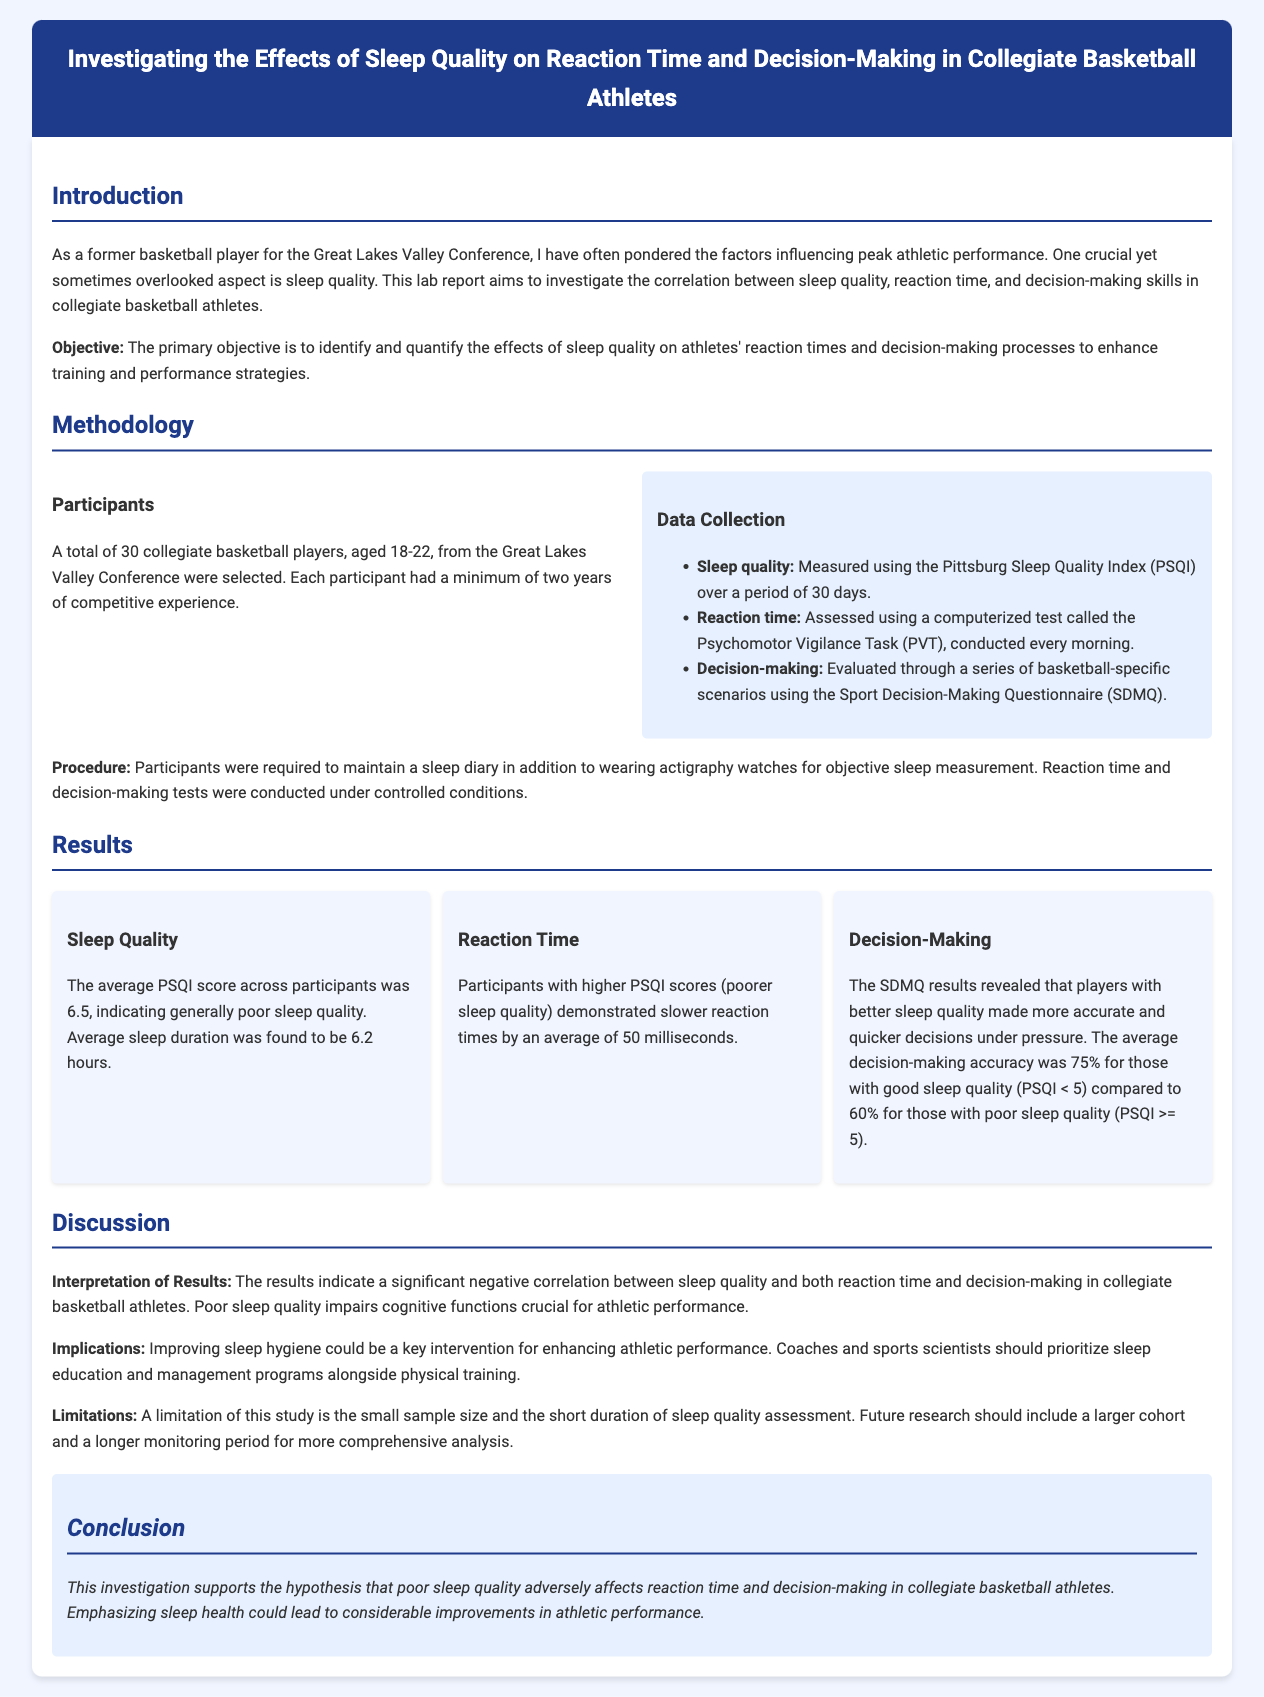what is the average PSQI score of participants? The average PSQI score across participants indicates generally poor sleep quality.
Answer: 6.5 how many collegiate basketball players participated in the study? The total number of collegiate basketball players selected for the study was specified in the document.
Answer: 30 what is the average sleep duration found in the study? The average sleep duration is based on the participant's sleep records over a specific period.
Answer: 6.2 hours how much slower were participants with poorer sleep quality in reaction times? Reaction times were measured and the impact of sleep quality on these times was analyzed.
Answer: 50 milliseconds what was the decision-making accuracy for those with good sleep quality? The decision-making results were reported as a percentage based on the PSQI scores of the participants.
Answer: 75% what is one implication suggested in the discussion? The discussion section highlights a recommendation based on the study's findings regarding sleep and athletic performance.
Answer: Sleep education what does the report suggest as a key intervention for enhancing athletic performance? The report indicates a specific area of focus to improve performance based on the results.
Answer: Improving sleep hygiene what tool was used to measure reaction time? The document identifies the specific computerized assessment used for reaction time measurement.
Answer: Psychomotor Vigilance Task what is one limitation mentioned in the study? Limitations of the study provide context to the findings and the methods used in the research.
Answer: Small sample size 